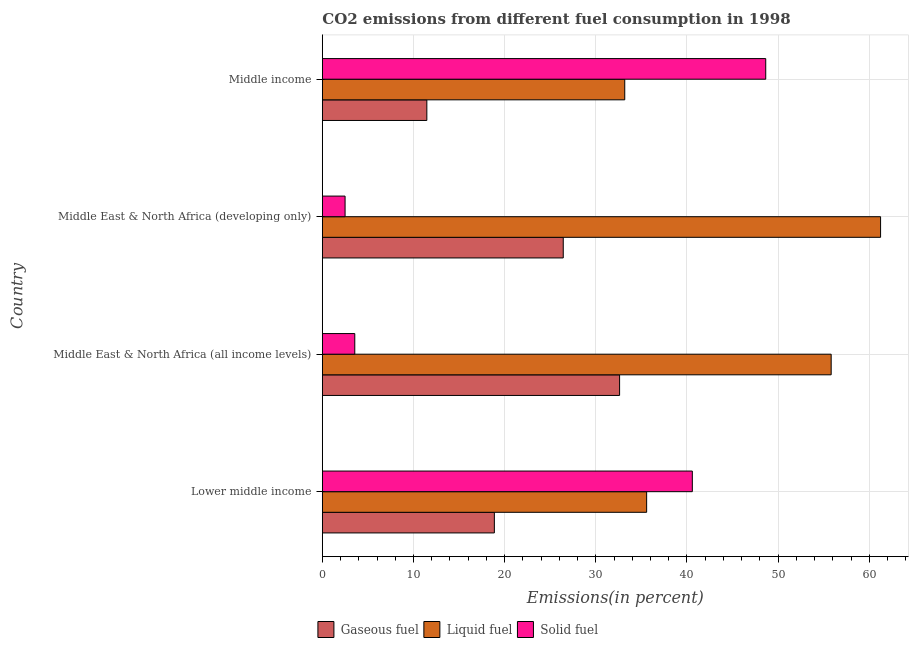How many different coloured bars are there?
Your answer should be very brief. 3. Are the number of bars per tick equal to the number of legend labels?
Your answer should be very brief. Yes. Are the number of bars on each tick of the Y-axis equal?
Your response must be concise. Yes. What is the label of the 4th group of bars from the top?
Your answer should be compact. Lower middle income. What is the percentage of solid fuel emission in Lower middle income?
Ensure brevity in your answer.  40.59. Across all countries, what is the maximum percentage of solid fuel emission?
Keep it short and to the point. 48.64. Across all countries, what is the minimum percentage of solid fuel emission?
Ensure brevity in your answer.  2.5. In which country was the percentage of liquid fuel emission maximum?
Your answer should be compact. Middle East & North Africa (developing only). In which country was the percentage of solid fuel emission minimum?
Provide a short and direct response. Middle East & North Africa (developing only). What is the total percentage of gaseous fuel emission in the graph?
Your response must be concise. 89.38. What is the difference between the percentage of solid fuel emission in Middle East & North Africa (all income levels) and that in Middle East & North Africa (developing only)?
Ensure brevity in your answer.  1.06. What is the difference between the percentage of liquid fuel emission in Lower middle income and the percentage of gaseous fuel emission in Middle East & North Africa (all income levels)?
Your answer should be compact. 2.97. What is the average percentage of gaseous fuel emission per country?
Give a very brief answer. 22.35. What is the difference between the percentage of gaseous fuel emission and percentage of solid fuel emission in Middle East & North Africa (all income levels)?
Offer a terse response. 29.05. What is the ratio of the percentage of liquid fuel emission in Lower middle income to that in Middle income?
Offer a terse response. 1.07. Is the percentage of solid fuel emission in Lower middle income less than that in Middle East & North Africa (all income levels)?
Offer a terse response. No. What is the difference between the highest and the second highest percentage of solid fuel emission?
Offer a terse response. 8.05. What is the difference between the highest and the lowest percentage of solid fuel emission?
Make the answer very short. 46.15. In how many countries, is the percentage of liquid fuel emission greater than the average percentage of liquid fuel emission taken over all countries?
Provide a succinct answer. 2. What does the 2nd bar from the top in Middle East & North Africa (developing only) represents?
Make the answer very short. Liquid fuel. What does the 1st bar from the bottom in Middle East & North Africa (developing only) represents?
Your answer should be very brief. Gaseous fuel. Are all the bars in the graph horizontal?
Ensure brevity in your answer.  Yes. Where does the legend appear in the graph?
Your answer should be compact. Bottom center. What is the title of the graph?
Offer a very short reply. CO2 emissions from different fuel consumption in 1998. Does "Travel services" appear as one of the legend labels in the graph?
Your answer should be very brief. No. What is the label or title of the X-axis?
Your response must be concise. Emissions(in percent). What is the label or title of the Y-axis?
Provide a short and direct response. Country. What is the Emissions(in percent) of Gaseous fuel in Lower middle income?
Provide a succinct answer. 18.87. What is the Emissions(in percent) in Liquid fuel in Lower middle income?
Your response must be concise. 35.58. What is the Emissions(in percent) in Solid fuel in Lower middle income?
Provide a succinct answer. 40.59. What is the Emissions(in percent) in Gaseous fuel in Middle East & North Africa (all income levels)?
Give a very brief answer. 32.61. What is the Emissions(in percent) in Liquid fuel in Middle East & North Africa (all income levels)?
Make the answer very short. 55.82. What is the Emissions(in percent) of Solid fuel in Middle East & North Africa (all income levels)?
Give a very brief answer. 3.56. What is the Emissions(in percent) of Gaseous fuel in Middle East & North Africa (developing only)?
Offer a very short reply. 26.43. What is the Emissions(in percent) of Liquid fuel in Middle East & North Africa (developing only)?
Provide a short and direct response. 61.24. What is the Emissions(in percent) of Solid fuel in Middle East & North Africa (developing only)?
Offer a terse response. 2.5. What is the Emissions(in percent) in Gaseous fuel in Middle income?
Your answer should be very brief. 11.47. What is the Emissions(in percent) of Liquid fuel in Middle income?
Keep it short and to the point. 33.18. What is the Emissions(in percent) in Solid fuel in Middle income?
Ensure brevity in your answer.  48.64. Across all countries, what is the maximum Emissions(in percent) in Gaseous fuel?
Keep it short and to the point. 32.61. Across all countries, what is the maximum Emissions(in percent) of Liquid fuel?
Provide a succinct answer. 61.24. Across all countries, what is the maximum Emissions(in percent) in Solid fuel?
Provide a short and direct response. 48.64. Across all countries, what is the minimum Emissions(in percent) of Gaseous fuel?
Make the answer very short. 11.47. Across all countries, what is the minimum Emissions(in percent) of Liquid fuel?
Ensure brevity in your answer.  33.18. Across all countries, what is the minimum Emissions(in percent) of Solid fuel?
Ensure brevity in your answer.  2.5. What is the total Emissions(in percent) in Gaseous fuel in the graph?
Your answer should be very brief. 89.38. What is the total Emissions(in percent) of Liquid fuel in the graph?
Provide a short and direct response. 185.83. What is the total Emissions(in percent) of Solid fuel in the graph?
Provide a succinct answer. 95.29. What is the difference between the Emissions(in percent) of Gaseous fuel in Lower middle income and that in Middle East & North Africa (all income levels)?
Offer a terse response. -13.74. What is the difference between the Emissions(in percent) of Liquid fuel in Lower middle income and that in Middle East & North Africa (all income levels)?
Your response must be concise. -20.24. What is the difference between the Emissions(in percent) of Solid fuel in Lower middle income and that in Middle East & North Africa (all income levels)?
Ensure brevity in your answer.  37.03. What is the difference between the Emissions(in percent) in Gaseous fuel in Lower middle income and that in Middle East & North Africa (developing only)?
Keep it short and to the point. -7.56. What is the difference between the Emissions(in percent) of Liquid fuel in Lower middle income and that in Middle East & North Africa (developing only)?
Ensure brevity in your answer.  -25.66. What is the difference between the Emissions(in percent) in Solid fuel in Lower middle income and that in Middle East & North Africa (developing only)?
Keep it short and to the point. 38.1. What is the difference between the Emissions(in percent) of Gaseous fuel in Lower middle income and that in Middle income?
Ensure brevity in your answer.  7.41. What is the difference between the Emissions(in percent) in Liquid fuel in Lower middle income and that in Middle income?
Provide a short and direct response. 2.4. What is the difference between the Emissions(in percent) of Solid fuel in Lower middle income and that in Middle income?
Your answer should be very brief. -8.05. What is the difference between the Emissions(in percent) of Gaseous fuel in Middle East & North Africa (all income levels) and that in Middle East & North Africa (developing only)?
Give a very brief answer. 6.18. What is the difference between the Emissions(in percent) of Liquid fuel in Middle East & North Africa (all income levels) and that in Middle East & North Africa (developing only)?
Your answer should be compact. -5.42. What is the difference between the Emissions(in percent) of Solid fuel in Middle East & North Africa (all income levels) and that in Middle East & North Africa (developing only)?
Provide a succinct answer. 1.06. What is the difference between the Emissions(in percent) of Gaseous fuel in Middle East & North Africa (all income levels) and that in Middle income?
Offer a very short reply. 21.15. What is the difference between the Emissions(in percent) of Liquid fuel in Middle East & North Africa (all income levels) and that in Middle income?
Ensure brevity in your answer.  22.65. What is the difference between the Emissions(in percent) of Solid fuel in Middle East & North Africa (all income levels) and that in Middle income?
Your response must be concise. -45.08. What is the difference between the Emissions(in percent) of Gaseous fuel in Middle East & North Africa (developing only) and that in Middle income?
Offer a terse response. 14.97. What is the difference between the Emissions(in percent) in Liquid fuel in Middle East & North Africa (developing only) and that in Middle income?
Your response must be concise. 28.07. What is the difference between the Emissions(in percent) in Solid fuel in Middle East & North Africa (developing only) and that in Middle income?
Ensure brevity in your answer.  -46.15. What is the difference between the Emissions(in percent) of Gaseous fuel in Lower middle income and the Emissions(in percent) of Liquid fuel in Middle East & North Africa (all income levels)?
Keep it short and to the point. -36.95. What is the difference between the Emissions(in percent) of Gaseous fuel in Lower middle income and the Emissions(in percent) of Solid fuel in Middle East & North Africa (all income levels)?
Offer a terse response. 15.31. What is the difference between the Emissions(in percent) of Liquid fuel in Lower middle income and the Emissions(in percent) of Solid fuel in Middle East & North Africa (all income levels)?
Offer a terse response. 32.02. What is the difference between the Emissions(in percent) in Gaseous fuel in Lower middle income and the Emissions(in percent) in Liquid fuel in Middle East & North Africa (developing only)?
Offer a terse response. -42.37. What is the difference between the Emissions(in percent) in Gaseous fuel in Lower middle income and the Emissions(in percent) in Solid fuel in Middle East & North Africa (developing only)?
Offer a terse response. 16.38. What is the difference between the Emissions(in percent) in Liquid fuel in Lower middle income and the Emissions(in percent) in Solid fuel in Middle East & North Africa (developing only)?
Your answer should be very brief. 33.08. What is the difference between the Emissions(in percent) of Gaseous fuel in Lower middle income and the Emissions(in percent) of Liquid fuel in Middle income?
Keep it short and to the point. -14.31. What is the difference between the Emissions(in percent) of Gaseous fuel in Lower middle income and the Emissions(in percent) of Solid fuel in Middle income?
Provide a succinct answer. -29.77. What is the difference between the Emissions(in percent) of Liquid fuel in Lower middle income and the Emissions(in percent) of Solid fuel in Middle income?
Your answer should be compact. -13.07. What is the difference between the Emissions(in percent) in Gaseous fuel in Middle East & North Africa (all income levels) and the Emissions(in percent) in Liquid fuel in Middle East & North Africa (developing only)?
Your answer should be very brief. -28.63. What is the difference between the Emissions(in percent) of Gaseous fuel in Middle East & North Africa (all income levels) and the Emissions(in percent) of Solid fuel in Middle East & North Africa (developing only)?
Offer a very short reply. 30.12. What is the difference between the Emissions(in percent) of Liquid fuel in Middle East & North Africa (all income levels) and the Emissions(in percent) of Solid fuel in Middle East & North Africa (developing only)?
Give a very brief answer. 53.33. What is the difference between the Emissions(in percent) of Gaseous fuel in Middle East & North Africa (all income levels) and the Emissions(in percent) of Liquid fuel in Middle income?
Give a very brief answer. -0.57. What is the difference between the Emissions(in percent) in Gaseous fuel in Middle East & North Africa (all income levels) and the Emissions(in percent) in Solid fuel in Middle income?
Your answer should be very brief. -16.03. What is the difference between the Emissions(in percent) in Liquid fuel in Middle East & North Africa (all income levels) and the Emissions(in percent) in Solid fuel in Middle income?
Make the answer very short. 7.18. What is the difference between the Emissions(in percent) of Gaseous fuel in Middle East & North Africa (developing only) and the Emissions(in percent) of Liquid fuel in Middle income?
Provide a succinct answer. -6.75. What is the difference between the Emissions(in percent) of Gaseous fuel in Middle East & North Africa (developing only) and the Emissions(in percent) of Solid fuel in Middle income?
Provide a succinct answer. -22.21. What is the difference between the Emissions(in percent) in Liquid fuel in Middle East & North Africa (developing only) and the Emissions(in percent) in Solid fuel in Middle income?
Your answer should be very brief. 12.6. What is the average Emissions(in percent) in Gaseous fuel per country?
Provide a short and direct response. 22.35. What is the average Emissions(in percent) in Liquid fuel per country?
Give a very brief answer. 46.46. What is the average Emissions(in percent) in Solid fuel per country?
Make the answer very short. 23.82. What is the difference between the Emissions(in percent) in Gaseous fuel and Emissions(in percent) in Liquid fuel in Lower middle income?
Ensure brevity in your answer.  -16.71. What is the difference between the Emissions(in percent) in Gaseous fuel and Emissions(in percent) in Solid fuel in Lower middle income?
Offer a very short reply. -21.72. What is the difference between the Emissions(in percent) of Liquid fuel and Emissions(in percent) of Solid fuel in Lower middle income?
Provide a succinct answer. -5.01. What is the difference between the Emissions(in percent) of Gaseous fuel and Emissions(in percent) of Liquid fuel in Middle East & North Africa (all income levels)?
Provide a short and direct response. -23.21. What is the difference between the Emissions(in percent) of Gaseous fuel and Emissions(in percent) of Solid fuel in Middle East & North Africa (all income levels)?
Your answer should be compact. 29.05. What is the difference between the Emissions(in percent) in Liquid fuel and Emissions(in percent) in Solid fuel in Middle East & North Africa (all income levels)?
Ensure brevity in your answer.  52.26. What is the difference between the Emissions(in percent) in Gaseous fuel and Emissions(in percent) in Liquid fuel in Middle East & North Africa (developing only)?
Your answer should be compact. -34.81. What is the difference between the Emissions(in percent) of Gaseous fuel and Emissions(in percent) of Solid fuel in Middle East & North Africa (developing only)?
Your response must be concise. 23.94. What is the difference between the Emissions(in percent) of Liquid fuel and Emissions(in percent) of Solid fuel in Middle East & North Africa (developing only)?
Ensure brevity in your answer.  58.75. What is the difference between the Emissions(in percent) of Gaseous fuel and Emissions(in percent) of Liquid fuel in Middle income?
Your response must be concise. -21.71. What is the difference between the Emissions(in percent) of Gaseous fuel and Emissions(in percent) of Solid fuel in Middle income?
Ensure brevity in your answer.  -37.18. What is the difference between the Emissions(in percent) in Liquid fuel and Emissions(in percent) in Solid fuel in Middle income?
Ensure brevity in your answer.  -15.47. What is the ratio of the Emissions(in percent) of Gaseous fuel in Lower middle income to that in Middle East & North Africa (all income levels)?
Provide a short and direct response. 0.58. What is the ratio of the Emissions(in percent) of Liquid fuel in Lower middle income to that in Middle East & North Africa (all income levels)?
Your answer should be compact. 0.64. What is the ratio of the Emissions(in percent) of Solid fuel in Lower middle income to that in Middle East & North Africa (all income levels)?
Provide a succinct answer. 11.4. What is the ratio of the Emissions(in percent) in Gaseous fuel in Lower middle income to that in Middle East & North Africa (developing only)?
Make the answer very short. 0.71. What is the ratio of the Emissions(in percent) in Liquid fuel in Lower middle income to that in Middle East & North Africa (developing only)?
Offer a terse response. 0.58. What is the ratio of the Emissions(in percent) of Solid fuel in Lower middle income to that in Middle East & North Africa (developing only)?
Provide a succinct answer. 16.26. What is the ratio of the Emissions(in percent) in Gaseous fuel in Lower middle income to that in Middle income?
Offer a very short reply. 1.65. What is the ratio of the Emissions(in percent) of Liquid fuel in Lower middle income to that in Middle income?
Your response must be concise. 1.07. What is the ratio of the Emissions(in percent) in Solid fuel in Lower middle income to that in Middle income?
Your answer should be compact. 0.83. What is the ratio of the Emissions(in percent) of Gaseous fuel in Middle East & North Africa (all income levels) to that in Middle East & North Africa (developing only)?
Your answer should be compact. 1.23. What is the ratio of the Emissions(in percent) of Liquid fuel in Middle East & North Africa (all income levels) to that in Middle East & North Africa (developing only)?
Ensure brevity in your answer.  0.91. What is the ratio of the Emissions(in percent) of Solid fuel in Middle East & North Africa (all income levels) to that in Middle East & North Africa (developing only)?
Ensure brevity in your answer.  1.43. What is the ratio of the Emissions(in percent) in Gaseous fuel in Middle East & North Africa (all income levels) to that in Middle income?
Provide a succinct answer. 2.84. What is the ratio of the Emissions(in percent) in Liquid fuel in Middle East & North Africa (all income levels) to that in Middle income?
Your answer should be very brief. 1.68. What is the ratio of the Emissions(in percent) of Solid fuel in Middle East & North Africa (all income levels) to that in Middle income?
Provide a short and direct response. 0.07. What is the ratio of the Emissions(in percent) in Gaseous fuel in Middle East & North Africa (developing only) to that in Middle income?
Provide a short and direct response. 2.31. What is the ratio of the Emissions(in percent) in Liquid fuel in Middle East & North Africa (developing only) to that in Middle income?
Your answer should be compact. 1.85. What is the ratio of the Emissions(in percent) in Solid fuel in Middle East & North Africa (developing only) to that in Middle income?
Make the answer very short. 0.05. What is the difference between the highest and the second highest Emissions(in percent) of Gaseous fuel?
Your answer should be compact. 6.18. What is the difference between the highest and the second highest Emissions(in percent) in Liquid fuel?
Give a very brief answer. 5.42. What is the difference between the highest and the second highest Emissions(in percent) in Solid fuel?
Ensure brevity in your answer.  8.05. What is the difference between the highest and the lowest Emissions(in percent) in Gaseous fuel?
Your answer should be very brief. 21.15. What is the difference between the highest and the lowest Emissions(in percent) of Liquid fuel?
Make the answer very short. 28.07. What is the difference between the highest and the lowest Emissions(in percent) in Solid fuel?
Provide a succinct answer. 46.15. 